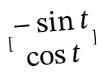<formula> <loc_0><loc_0><loc_500><loc_500>[ \begin{matrix} - \sin t \\ \cos t \end{matrix} ]</formula> 